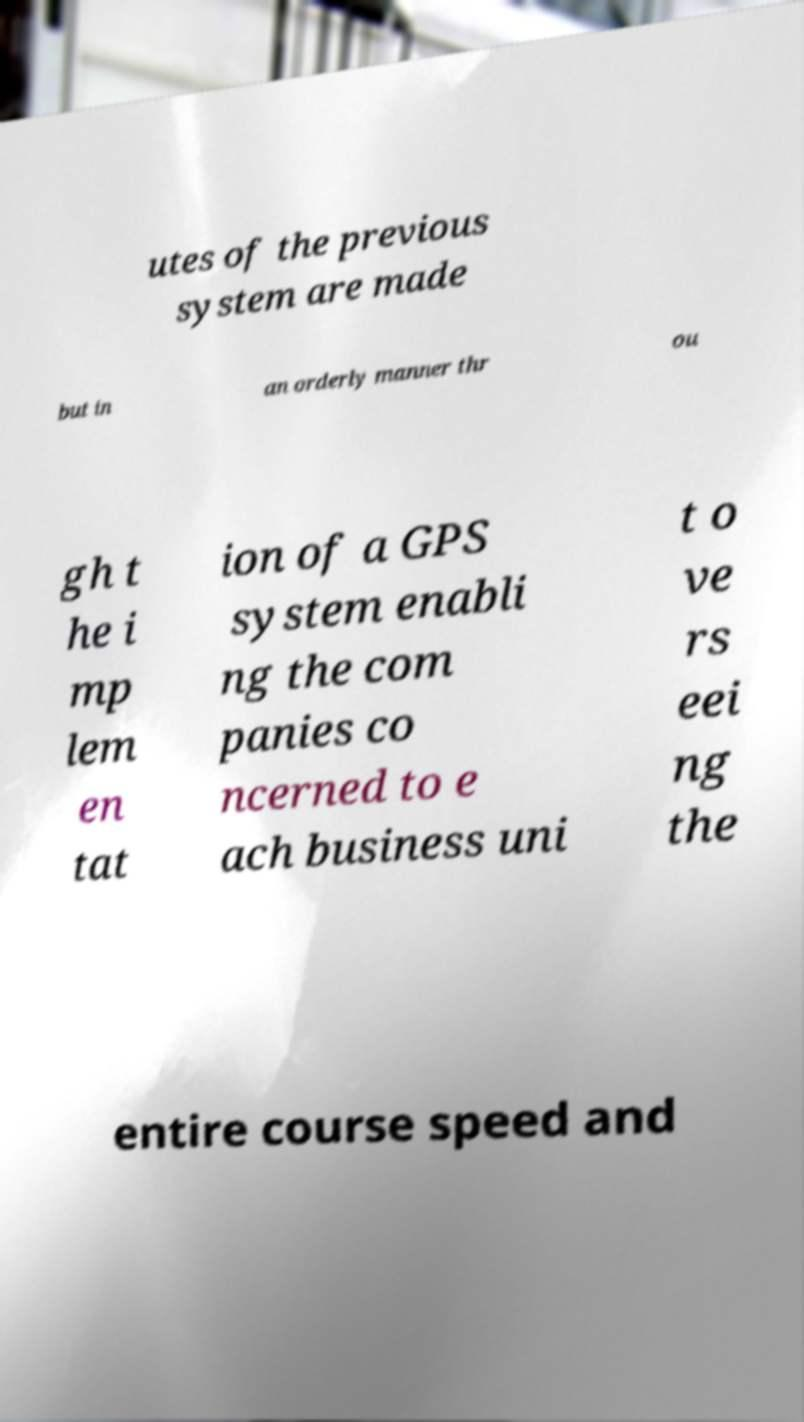Please read and relay the text visible in this image. What does it say? utes of the previous system are made but in an orderly manner thr ou gh t he i mp lem en tat ion of a GPS system enabli ng the com panies co ncerned to e ach business uni t o ve rs eei ng the entire course speed and 